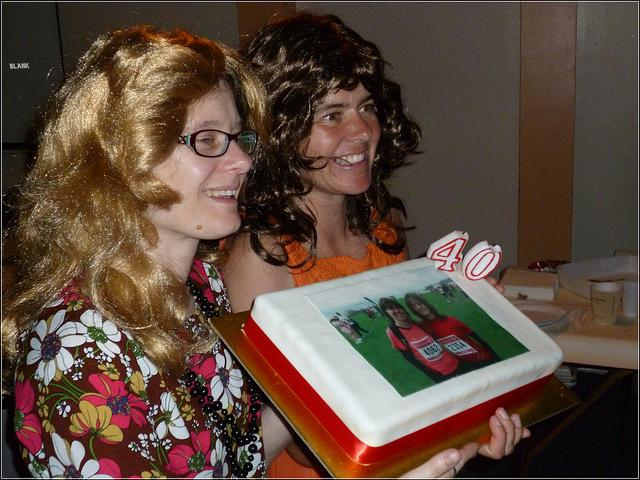How old is the birthday girl? 40 